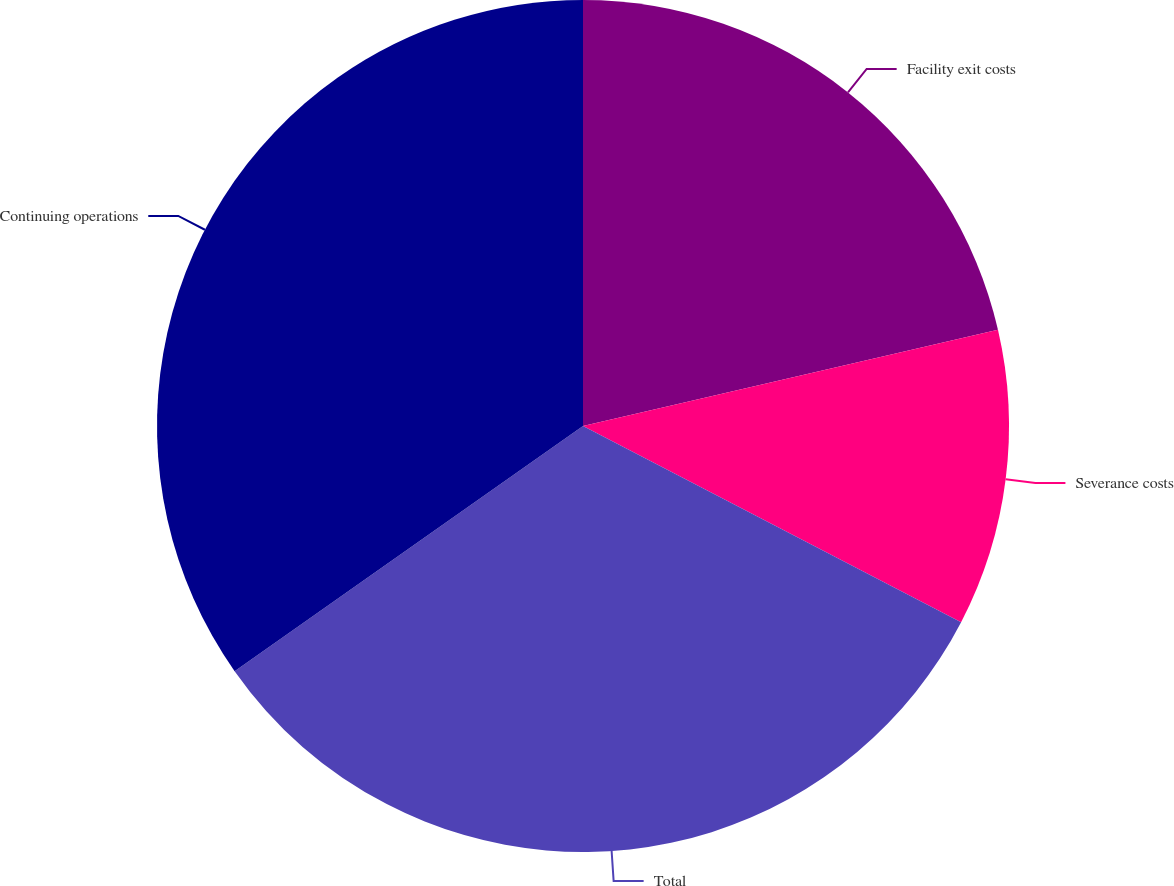Convert chart. <chart><loc_0><loc_0><loc_500><loc_500><pie_chart><fcel>Facility exit costs<fcel>Severance costs<fcel>Total<fcel>Continuing operations<nl><fcel>21.37%<fcel>11.25%<fcel>32.62%<fcel>34.76%<nl></chart> 